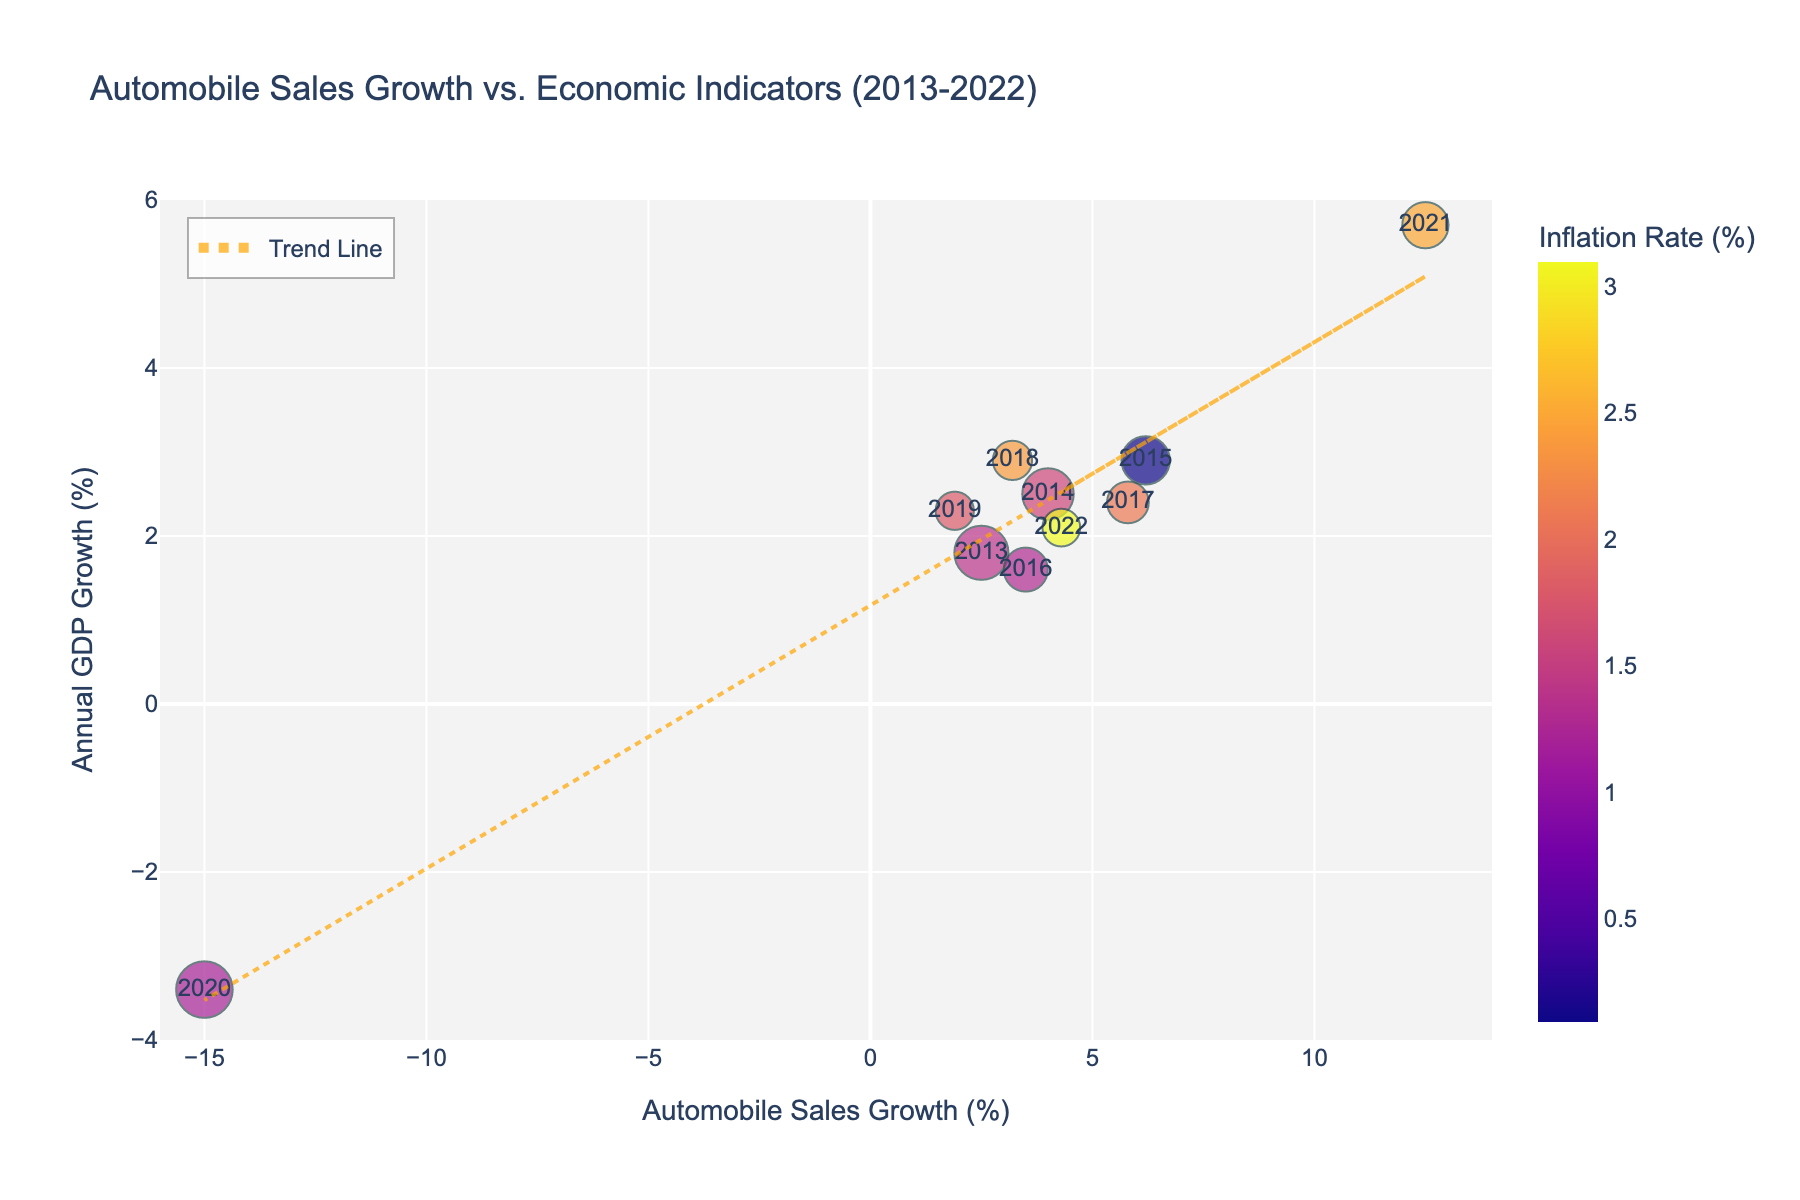What is the title of the plot? The title is displayed at the top of the figure, which describes what the plot is about. The title is "Automobile Sales Growth vs. Economic Indicators (2013-2022)"
Answer: Automobile Sales Growth vs. Economic Indicators (2013-2022) How many data points are there in the scatter plot? Each year from 2013 to 2022 represents one data point in the scatter plot. There are 10 years in this range.
Answer: 10 What is the trend in the automobile sales growth from 2013 to 2022? Observe the trend line in the scatter plot that represents the equation of best fit. The trend shows overall growth despite fluctuations, peaking at a positive value before dipping and recovering dramatically.
Answer: Overall positive growth Which year had the highest automobile sales growth? Hovering over each data point, you can see the hover text which shows the exact year. The data point with the highest y-value for automobile sales growth has 12.5%, which corresponds to the year 2021.
Answer: 2021 How does the unemployment rate correlate to the size of data points? The size of each data point in the scatter plot is determined by the unemployment rate. Larger data points correspond to higher unemployment rates. For instance, the largest data point follows the year with an 8.1% unemployment rate, which is 2020.
Answer: Larger sizes indicate higher unemployment rates What is the color of the data point representing the year 2022? The color scale represents the inflation rate, and the color for 2022 matches the highest end of the color bar. It shows a corresponding high inflation rate of 3.1%.
Answer: Color matching the highest inflation rate on the color bar Which year had the largest unemployment rate and what was the economic growth in that year? By observing the size of the data points, 2020 appears to have the largest data point size. Hover over it to find its annual GDP growth, which is displayed as -3.4%.
Answer: 2020, -3.4% Compare the automobile sales growth in 2021 with 2015. Hover over the data points for 2021 and 2015. The text shows the automobile sales growth for 2021 was 12.5% while in 2015 it was 6.2%. 2021 had a significantly higher growth.
Answer: 12.5% vs. 6.2% What is the relationship between automobile sales growth and inflation rate, as observed in the plot? The color-gradient of the data points indicates inflation rates. Observing the plot, higher automobile sales growth often corresponds to various colors, indicating an inconsistent direct relationship between sales growth and inflation.
Answer: No consistent direct relationship 